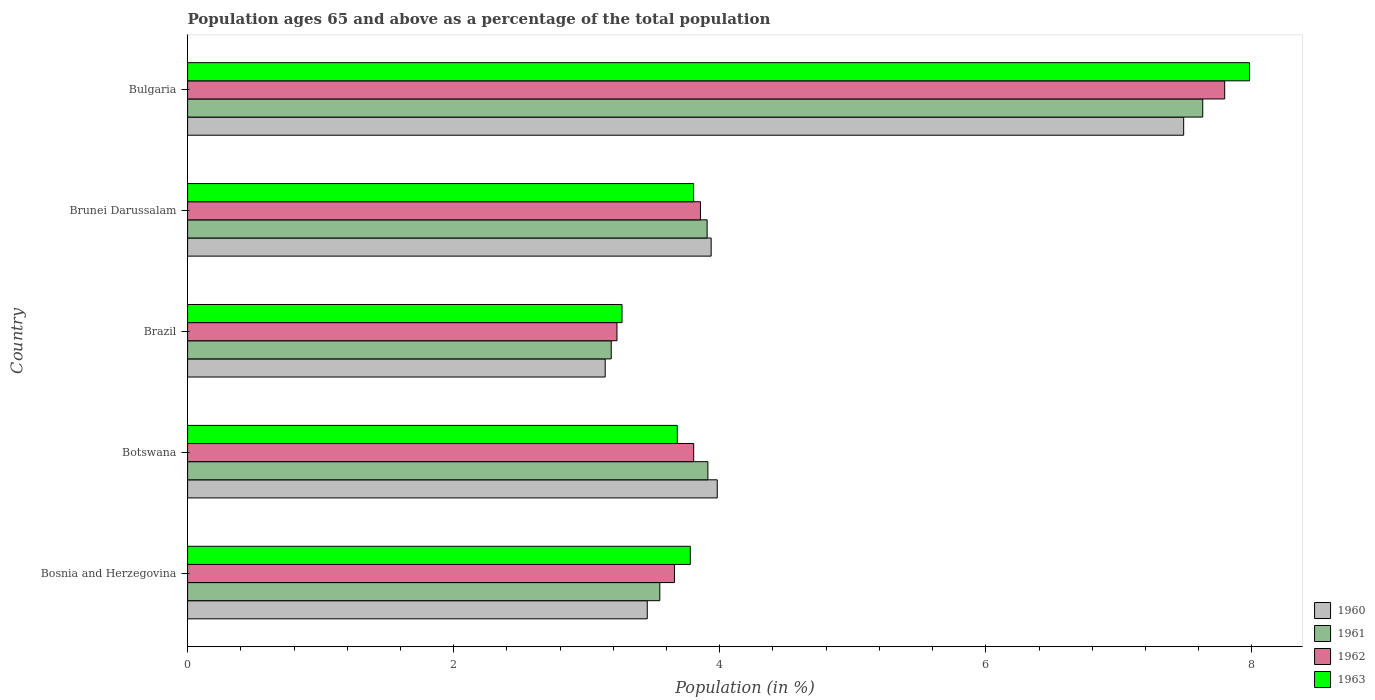How many different coloured bars are there?
Give a very brief answer. 4. How many groups of bars are there?
Give a very brief answer. 5. Are the number of bars on each tick of the Y-axis equal?
Provide a short and direct response. Yes. How many bars are there on the 3rd tick from the bottom?
Keep it short and to the point. 4. What is the label of the 5th group of bars from the top?
Your answer should be compact. Bosnia and Herzegovina. What is the percentage of the population ages 65 and above in 1963 in Botswana?
Ensure brevity in your answer.  3.68. Across all countries, what is the maximum percentage of the population ages 65 and above in 1961?
Provide a short and direct response. 7.63. Across all countries, what is the minimum percentage of the population ages 65 and above in 1961?
Provide a short and direct response. 3.18. What is the total percentage of the population ages 65 and above in 1962 in the graph?
Ensure brevity in your answer.  22.34. What is the difference between the percentage of the population ages 65 and above in 1960 in Bosnia and Herzegovina and that in Botswana?
Your answer should be very brief. -0.53. What is the difference between the percentage of the population ages 65 and above in 1960 in Botswana and the percentage of the population ages 65 and above in 1963 in Brazil?
Keep it short and to the point. 0.72. What is the average percentage of the population ages 65 and above in 1961 per country?
Make the answer very short. 4.44. What is the difference between the percentage of the population ages 65 and above in 1961 and percentage of the population ages 65 and above in 1962 in Bosnia and Herzegovina?
Offer a very short reply. -0.11. In how many countries, is the percentage of the population ages 65 and above in 1961 greater than 3.6 ?
Give a very brief answer. 3. What is the ratio of the percentage of the population ages 65 and above in 1962 in Brunei Darussalam to that in Bulgaria?
Offer a terse response. 0.49. Is the percentage of the population ages 65 and above in 1960 in Bosnia and Herzegovina less than that in Bulgaria?
Your response must be concise. Yes. What is the difference between the highest and the second highest percentage of the population ages 65 and above in 1962?
Provide a succinct answer. 3.94. What is the difference between the highest and the lowest percentage of the population ages 65 and above in 1963?
Make the answer very short. 4.72. Is it the case that in every country, the sum of the percentage of the population ages 65 and above in 1962 and percentage of the population ages 65 and above in 1961 is greater than the sum of percentage of the population ages 65 and above in 1960 and percentage of the population ages 65 and above in 1963?
Make the answer very short. No. What does the 2nd bar from the top in Brazil represents?
Your answer should be compact. 1962. Is it the case that in every country, the sum of the percentage of the population ages 65 and above in 1961 and percentage of the population ages 65 and above in 1960 is greater than the percentage of the population ages 65 and above in 1963?
Make the answer very short. Yes. How many bars are there?
Your answer should be compact. 20. Are all the bars in the graph horizontal?
Offer a terse response. Yes. What is the difference between two consecutive major ticks on the X-axis?
Ensure brevity in your answer.  2. Where does the legend appear in the graph?
Offer a very short reply. Bottom right. How many legend labels are there?
Your response must be concise. 4. What is the title of the graph?
Offer a terse response. Population ages 65 and above as a percentage of the total population. What is the label or title of the X-axis?
Provide a short and direct response. Population (in %). What is the Population (in %) of 1960 in Bosnia and Herzegovina?
Offer a terse response. 3.46. What is the Population (in %) of 1961 in Bosnia and Herzegovina?
Give a very brief answer. 3.55. What is the Population (in %) in 1962 in Bosnia and Herzegovina?
Offer a very short reply. 3.66. What is the Population (in %) of 1963 in Bosnia and Herzegovina?
Ensure brevity in your answer.  3.78. What is the Population (in %) in 1960 in Botswana?
Offer a very short reply. 3.98. What is the Population (in %) of 1961 in Botswana?
Your answer should be very brief. 3.91. What is the Population (in %) in 1962 in Botswana?
Provide a succinct answer. 3.8. What is the Population (in %) in 1963 in Botswana?
Ensure brevity in your answer.  3.68. What is the Population (in %) of 1960 in Brazil?
Ensure brevity in your answer.  3.14. What is the Population (in %) of 1961 in Brazil?
Ensure brevity in your answer.  3.18. What is the Population (in %) of 1962 in Brazil?
Provide a short and direct response. 3.23. What is the Population (in %) in 1963 in Brazil?
Provide a succinct answer. 3.27. What is the Population (in %) in 1960 in Brunei Darussalam?
Make the answer very short. 3.94. What is the Population (in %) of 1961 in Brunei Darussalam?
Make the answer very short. 3.9. What is the Population (in %) of 1962 in Brunei Darussalam?
Keep it short and to the point. 3.85. What is the Population (in %) in 1963 in Brunei Darussalam?
Give a very brief answer. 3.8. What is the Population (in %) in 1960 in Bulgaria?
Offer a terse response. 7.49. What is the Population (in %) of 1961 in Bulgaria?
Make the answer very short. 7.63. What is the Population (in %) in 1962 in Bulgaria?
Your answer should be compact. 7.8. What is the Population (in %) in 1963 in Bulgaria?
Provide a short and direct response. 7.98. Across all countries, what is the maximum Population (in %) of 1960?
Provide a succinct answer. 7.49. Across all countries, what is the maximum Population (in %) in 1961?
Offer a terse response. 7.63. Across all countries, what is the maximum Population (in %) in 1962?
Offer a terse response. 7.8. Across all countries, what is the maximum Population (in %) of 1963?
Your answer should be very brief. 7.98. Across all countries, what is the minimum Population (in %) of 1960?
Your answer should be compact. 3.14. Across all countries, what is the minimum Population (in %) of 1961?
Your answer should be compact. 3.18. Across all countries, what is the minimum Population (in %) in 1962?
Give a very brief answer. 3.23. Across all countries, what is the minimum Population (in %) of 1963?
Offer a very short reply. 3.27. What is the total Population (in %) in 1960 in the graph?
Your answer should be very brief. 22. What is the total Population (in %) in 1961 in the graph?
Keep it short and to the point. 22.18. What is the total Population (in %) of 1962 in the graph?
Offer a very short reply. 22.34. What is the total Population (in %) of 1963 in the graph?
Your response must be concise. 22.51. What is the difference between the Population (in %) in 1960 in Bosnia and Herzegovina and that in Botswana?
Give a very brief answer. -0.53. What is the difference between the Population (in %) in 1961 in Bosnia and Herzegovina and that in Botswana?
Your answer should be very brief. -0.36. What is the difference between the Population (in %) in 1962 in Bosnia and Herzegovina and that in Botswana?
Make the answer very short. -0.14. What is the difference between the Population (in %) of 1963 in Bosnia and Herzegovina and that in Botswana?
Offer a very short reply. 0.1. What is the difference between the Population (in %) of 1960 in Bosnia and Herzegovina and that in Brazil?
Make the answer very short. 0.32. What is the difference between the Population (in %) in 1961 in Bosnia and Herzegovina and that in Brazil?
Offer a terse response. 0.37. What is the difference between the Population (in %) in 1962 in Bosnia and Herzegovina and that in Brazil?
Provide a succinct answer. 0.43. What is the difference between the Population (in %) in 1963 in Bosnia and Herzegovina and that in Brazil?
Give a very brief answer. 0.51. What is the difference between the Population (in %) of 1960 in Bosnia and Herzegovina and that in Brunei Darussalam?
Provide a short and direct response. -0.48. What is the difference between the Population (in %) in 1961 in Bosnia and Herzegovina and that in Brunei Darussalam?
Provide a succinct answer. -0.36. What is the difference between the Population (in %) of 1962 in Bosnia and Herzegovina and that in Brunei Darussalam?
Provide a short and direct response. -0.2. What is the difference between the Population (in %) in 1963 in Bosnia and Herzegovina and that in Brunei Darussalam?
Keep it short and to the point. -0.02. What is the difference between the Population (in %) of 1960 in Bosnia and Herzegovina and that in Bulgaria?
Provide a short and direct response. -4.03. What is the difference between the Population (in %) in 1961 in Bosnia and Herzegovina and that in Bulgaria?
Keep it short and to the point. -4.08. What is the difference between the Population (in %) of 1962 in Bosnia and Herzegovina and that in Bulgaria?
Your answer should be very brief. -4.14. What is the difference between the Population (in %) of 1963 in Bosnia and Herzegovina and that in Bulgaria?
Offer a very short reply. -4.2. What is the difference between the Population (in %) in 1960 in Botswana and that in Brazil?
Ensure brevity in your answer.  0.84. What is the difference between the Population (in %) in 1961 in Botswana and that in Brazil?
Your response must be concise. 0.73. What is the difference between the Population (in %) in 1962 in Botswana and that in Brazil?
Your response must be concise. 0.58. What is the difference between the Population (in %) of 1963 in Botswana and that in Brazil?
Provide a short and direct response. 0.42. What is the difference between the Population (in %) of 1960 in Botswana and that in Brunei Darussalam?
Give a very brief answer. 0.05. What is the difference between the Population (in %) in 1961 in Botswana and that in Brunei Darussalam?
Ensure brevity in your answer.  0.01. What is the difference between the Population (in %) of 1962 in Botswana and that in Brunei Darussalam?
Provide a short and direct response. -0.05. What is the difference between the Population (in %) in 1963 in Botswana and that in Brunei Darussalam?
Your answer should be very brief. -0.12. What is the difference between the Population (in %) of 1960 in Botswana and that in Bulgaria?
Offer a very short reply. -3.51. What is the difference between the Population (in %) in 1961 in Botswana and that in Bulgaria?
Offer a terse response. -3.72. What is the difference between the Population (in %) of 1962 in Botswana and that in Bulgaria?
Offer a terse response. -3.99. What is the difference between the Population (in %) in 1963 in Botswana and that in Bulgaria?
Ensure brevity in your answer.  -4.3. What is the difference between the Population (in %) in 1960 in Brazil and that in Brunei Darussalam?
Offer a very short reply. -0.8. What is the difference between the Population (in %) of 1961 in Brazil and that in Brunei Darussalam?
Your answer should be compact. -0.72. What is the difference between the Population (in %) of 1962 in Brazil and that in Brunei Darussalam?
Ensure brevity in your answer.  -0.63. What is the difference between the Population (in %) of 1963 in Brazil and that in Brunei Darussalam?
Your answer should be compact. -0.54. What is the difference between the Population (in %) in 1960 in Brazil and that in Bulgaria?
Provide a succinct answer. -4.35. What is the difference between the Population (in %) in 1961 in Brazil and that in Bulgaria?
Make the answer very short. -4.45. What is the difference between the Population (in %) of 1962 in Brazil and that in Bulgaria?
Your answer should be compact. -4.57. What is the difference between the Population (in %) in 1963 in Brazil and that in Bulgaria?
Your answer should be compact. -4.72. What is the difference between the Population (in %) in 1960 in Brunei Darussalam and that in Bulgaria?
Make the answer very short. -3.55. What is the difference between the Population (in %) in 1961 in Brunei Darussalam and that in Bulgaria?
Make the answer very short. -3.73. What is the difference between the Population (in %) of 1962 in Brunei Darussalam and that in Bulgaria?
Offer a very short reply. -3.94. What is the difference between the Population (in %) in 1963 in Brunei Darussalam and that in Bulgaria?
Ensure brevity in your answer.  -4.18. What is the difference between the Population (in %) of 1960 in Bosnia and Herzegovina and the Population (in %) of 1961 in Botswana?
Provide a succinct answer. -0.46. What is the difference between the Population (in %) of 1960 in Bosnia and Herzegovina and the Population (in %) of 1962 in Botswana?
Provide a succinct answer. -0.35. What is the difference between the Population (in %) of 1960 in Bosnia and Herzegovina and the Population (in %) of 1963 in Botswana?
Your response must be concise. -0.23. What is the difference between the Population (in %) of 1961 in Bosnia and Herzegovina and the Population (in %) of 1962 in Botswana?
Make the answer very short. -0.25. What is the difference between the Population (in %) in 1961 in Bosnia and Herzegovina and the Population (in %) in 1963 in Botswana?
Provide a succinct answer. -0.13. What is the difference between the Population (in %) of 1962 in Bosnia and Herzegovina and the Population (in %) of 1963 in Botswana?
Your response must be concise. -0.02. What is the difference between the Population (in %) of 1960 in Bosnia and Herzegovina and the Population (in %) of 1961 in Brazil?
Make the answer very short. 0.27. What is the difference between the Population (in %) of 1960 in Bosnia and Herzegovina and the Population (in %) of 1962 in Brazil?
Offer a terse response. 0.23. What is the difference between the Population (in %) in 1960 in Bosnia and Herzegovina and the Population (in %) in 1963 in Brazil?
Offer a terse response. 0.19. What is the difference between the Population (in %) in 1961 in Bosnia and Herzegovina and the Population (in %) in 1962 in Brazil?
Keep it short and to the point. 0.32. What is the difference between the Population (in %) in 1961 in Bosnia and Herzegovina and the Population (in %) in 1963 in Brazil?
Your answer should be very brief. 0.28. What is the difference between the Population (in %) of 1962 in Bosnia and Herzegovina and the Population (in %) of 1963 in Brazil?
Give a very brief answer. 0.39. What is the difference between the Population (in %) of 1960 in Bosnia and Herzegovina and the Population (in %) of 1961 in Brunei Darussalam?
Your response must be concise. -0.45. What is the difference between the Population (in %) in 1960 in Bosnia and Herzegovina and the Population (in %) in 1962 in Brunei Darussalam?
Ensure brevity in your answer.  -0.4. What is the difference between the Population (in %) in 1960 in Bosnia and Herzegovina and the Population (in %) in 1963 in Brunei Darussalam?
Make the answer very short. -0.35. What is the difference between the Population (in %) of 1961 in Bosnia and Herzegovina and the Population (in %) of 1962 in Brunei Darussalam?
Your answer should be very brief. -0.31. What is the difference between the Population (in %) in 1961 in Bosnia and Herzegovina and the Population (in %) in 1963 in Brunei Darussalam?
Ensure brevity in your answer.  -0.25. What is the difference between the Population (in %) in 1962 in Bosnia and Herzegovina and the Population (in %) in 1963 in Brunei Darussalam?
Ensure brevity in your answer.  -0.14. What is the difference between the Population (in %) in 1960 in Bosnia and Herzegovina and the Population (in %) in 1961 in Bulgaria?
Your response must be concise. -4.18. What is the difference between the Population (in %) of 1960 in Bosnia and Herzegovina and the Population (in %) of 1962 in Bulgaria?
Offer a terse response. -4.34. What is the difference between the Population (in %) in 1960 in Bosnia and Herzegovina and the Population (in %) in 1963 in Bulgaria?
Your answer should be very brief. -4.53. What is the difference between the Population (in %) in 1961 in Bosnia and Herzegovina and the Population (in %) in 1962 in Bulgaria?
Your answer should be compact. -4.25. What is the difference between the Population (in %) of 1961 in Bosnia and Herzegovina and the Population (in %) of 1963 in Bulgaria?
Your answer should be compact. -4.43. What is the difference between the Population (in %) in 1962 in Bosnia and Herzegovina and the Population (in %) in 1963 in Bulgaria?
Make the answer very short. -4.32. What is the difference between the Population (in %) of 1960 in Botswana and the Population (in %) of 1961 in Brazil?
Keep it short and to the point. 0.8. What is the difference between the Population (in %) of 1960 in Botswana and the Population (in %) of 1962 in Brazil?
Keep it short and to the point. 0.75. What is the difference between the Population (in %) of 1960 in Botswana and the Population (in %) of 1963 in Brazil?
Your response must be concise. 0.72. What is the difference between the Population (in %) in 1961 in Botswana and the Population (in %) in 1962 in Brazil?
Your answer should be very brief. 0.68. What is the difference between the Population (in %) in 1961 in Botswana and the Population (in %) in 1963 in Brazil?
Give a very brief answer. 0.65. What is the difference between the Population (in %) in 1962 in Botswana and the Population (in %) in 1963 in Brazil?
Offer a terse response. 0.54. What is the difference between the Population (in %) in 1960 in Botswana and the Population (in %) in 1961 in Brunei Darussalam?
Give a very brief answer. 0.08. What is the difference between the Population (in %) of 1960 in Botswana and the Population (in %) of 1962 in Brunei Darussalam?
Make the answer very short. 0.13. What is the difference between the Population (in %) in 1960 in Botswana and the Population (in %) in 1963 in Brunei Darussalam?
Offer a very short reply. 0.18. What is the difference between the Population (in %) of 1961 in Botswana and the Population (in %) of 1962 in Brunei Darussalam?
Your answer should be very brief. 0.06. What is the difference between the Population (in %) in 1961 in Botswana and the Population (in %) in 1963 in Brunei Darussalam?
Your answer should be compact. 0.11. What is the difference between the Population (in %) in 1962 in Botswana and the Population (in %) in 1963 in Brunei Darussalam?
Provide a succinct answer. 0. What is the difference between the Population (in %) of 1960 in Botswana and the Population (in %) of 1961 in Bulgaria?
Make the answer very short. -3.65. What is the difference between the Population (in %) in 1960 in Botswana and the Population (in %) in 1962 in Bulgaria?
Your answer should be very brief. -3.81. What is the difference between the Population (in %) of 1960 in Botswana and the Population (in %) of 1963 in Bulgaria?
Make the answer very short. -4. What is the difference between the Population (in %) in 1961 in Botswana and the Population (in %) in 1962 in Bulgaria?
Your answer should be very brief. -3.88. What is the difference between the Population (in %) of 1961 in Botswana and the Population (in %) of 1963 in Bulgaria?
Give a very brief answer. -4.07. What is the difference between the Population (in %) in 1962 in Botswana and the Population (in %) in 1963 in Bulgaria?
Offer a terse response. -4.18. What is the difference between the Population (in %) of 1960 in Brazil and the Population (in %) of 1961 in Brunei Darussalam?
Ensure brevity in your answer.  -0.77. What is the difference between the Population (in %) of 1960 in Brazil and the Population (in %) of 1962 in Brunei Darussalam?
Provide a short and direct response. -0.72. What is the difference between the Population (in %) of 1960 in Brazil and the Population (in %) of 1963 in Brunei Darussalam?
Give a very brief answer. -0.66. What is the difference between the Population (in %) of 1961 in Brazil and the Population (in %) of 1962 in Brunei Darussalam?
Make the answer very short. -0.67. What is the difference between the Population (in %) in 1961 in Brazil and the Population (in %) in 1963 in Brunei Darussalam?
Offer a terse response. -0.62. What is the difference between the Population (in %) in 1962 in Brazil and the Population (in %) in 1963 in Brunei Darussalam?
Provide a short and direct response. -0.58. What is the difference between the Population (in %) in 1960 in Brazil and the Population (in %) in 1961 in Bulgaria?
Provide a short and direct response. -4.49. What is the difference between the Population (in %) of 1960 in Brazil and the Population (in %) of 1962 in Bulgaria?
Make the answer very short. -4.66. What is the difference between the Population (in %) of 1960 in Brazil and the Population (in %) of 1963 in Bulgaria?
Your answer should be very brief. -4.84. What is the difference between the Population (in %) in 1961 in Brazil and the Population (in %) in 1962 in Bulgaria?
Ensure brevity in your answer.  -4.61. What is the difference between the Population (in %) of 1961 in Brazil and the Population (in %) of 1963 in Bulgaria?
Offer a terse response. -4.8. What is the difference between the Population (in %) of 1962 in Brazil and the Population (in %) of 1963 in Bulgaria?
Ensure brevity in your answer.  -4.75. What is the difference between the Population (in %) of 1960 in Brunei Darussalam and the Population (in %) of 1961 in Bulgaria?
Offer a terse response. -3.69. What is the difference between the Population (in %) in 1960 in Brunei Darussalam and the Population (in %) in 1962 in Bulgaria?
Give a very brief answer. -3.86. What is the difference between the Population (in %) in 1960 in Brunei Darussalam and the Population (in %) in 1963 in Bulgaria?
Your answer should be compact. -4.05. What is the difference between the Population (in %) of 1961 in Brunei Darussalam and the Population (in %) of 1962 in Bulgaria?
Ensure brevity in your answer.  -3.89. What is the difference between the Population (in %) in 1961 in Brunei Darussalam and the Population (in %) in 1963 in Bulgaria?
Keep it short and to the point. -4.08. What is the difference between the Population (in %) of 1962 in Brunei Darussalam and the Population (in %) of 1963 in Bulgaria?
Your response must be concise. -4.13. What is the average Population (in %) of 1960 per country?
Make the answer very short. 4.4. What is the average Population (in %) in 1961 per country?
Ensure brevity in your answer.  4.44. What is the average Population (in %) in 1962 per country?
Provide a short and direct response. 4.47. What is the average Population (in %) of 1963 per country?
Offer a terse response. 4.5. What is the difference between the Population (in %) in 1960 and Population (in %) in 1961 in Bosnia and Herzegovina?
Your answer should be compact. -0.09. What is the difference between the Population (in %) of 1960 and Population (in %) of 1962 in Bosnia and Herzegovina?
Ensure brevity in your answer.  -0.2. What is the difference between the Population (in %) of 1960 and Population (in %) of 1963 in Bosnia and Herzegovina?
Provide a succinct answer. -0.32. What is the difference between the Population (in %) in 1961 and Population (in %) in 1962 in Bosnia and Herzegovina?
Offer a terse response. -0.11. What is the difference between the Population (in %) in 1961 and Population (in %) in 1963 in Bosnia and Herzegovina?
Your answer should be very brief. -0.23. What is the difference between the Population (in %) in 1962 and Population (in %) in 1963 in Bosnia and Herzegovina?
Keep it short and to the point. -0.12. What is the difference between the Population (in %) in 1960 and Population (in %) in 1961 in Botswana?
Offer a terse response. 0.07. What is the difference between the Population (in %) in 1960 and Population (in %) in 1962 in Botswana?
Your answer should be very brief. 0.18. What is the difference between the Population (in %) of 1960 and Population (in %) of 1963 in Botswana?
Offer a terse response. 0.3. What is the difference between the Population (in %) of 1961 and Population (in %) of 1962 in Botswana?
Provide a succinct answer. 0.11. What is the difference between the Population (in %) in 1961 and Population (in %) in 1963 in Botswana?
Provide a succinct answer. 0.23. What is the difference between the Population (in %) of 1962 and Population (in %) of 1963 in Botswana?
Give a very brief answer. 0.12. What is the difference between the Population (in %) of 1960 and Population (in %) of 1961 in Brazil?
Your answer should be very brief. -0.05. What is the difference between the Population (in %) of 1960 and Population (in %) of 1962 in Brazil?
Offer a very short reply. -0.09. What is the difference between the Population (in %) of 1960 and Population (in %) of 1963 in Brazil?
Your answer should be compact. -0.13. What is the difference between the Population (in %) of 1961 and Population (in %) of 1962 in Brazil?
Offer a terse response. -0.04. What is the difference between the Population (in %) of 1961 and Population (in %) of 1963 in Brazil?
Provide a short and direct response. -0.08. What is the difference between the Population (in %) in 1962 and Population (in %) in 1963 in Brazil?
Make the answer very short. -0.04. What is the difference between the Population (in %) in 1960 and Population (in %) in 1961 in Brunei Darussalam?
Provide a short and direct response. 0.03. What is the difference between the Population (in %) in 1960 and Population (in %) in 1962 in Brunei Darussalam?
Offer a very short reply. 0.08. What is the difference between the Population (in %) in 1960 and Population (in %) in 1963 in Brunei Darussalam?
Give a very brief answer. 0.13. What is the difference between the Population (in %) of 1961 and Population (in %) of 1962 in Brunei Darussalam?
Provide a short and direct response. 0.05. What is the difference between the Population (in %) in 1961 and Population (in %) in 1963 in Brunei Darussalam?
Offer a very short reply. 0.1. What is the difference between the Population (in %) of 1962 and Population (in %) of 1963 in Brunei Darussalam?
Make the answer very short. 0.05. What is the difference between the Population (in %) in 1960 and Population (in %) in 1961 in Bulgaria?
Give a very brief answer. -0.14. What is the difference between the Population (in %) of 1960 and Population (in %) of 1962 in Bulgaria?
Offer a terse response. -0.31. What is the difference between the Population (in %) in 1960 and Population (in %) in 1963 in Bulgaria?
Make the answer very short. -0.49. What is the difference between the Population (in %) in 1961 and Population (in %) in 1962 in Bulgaria?
Provide a succinct answer. -0.17. What is the difference between the Population (in %) of 1961 and Population (in %) of 1963 in Bulgaria?
Your answer should be very brief. -0.35. What is the difference between the Population (in %) in 1962 and Population (in %) in 1963 in Bulgaria?
Provide a succinct answer. -0.19. What is the ratio of the Population (in %) of 1960 in Bosnia and Herzegovina to that in Botswana?
Your response must be concise. 0.87. What is the ratio of the Population (in %) in 1961 in Bosnia and Herzegovina to that in Botswana?
Your response must be concise. 0.91. What is the ratio of the Population (in %) in 1963 in Bosnia and Herzegovina to that in Botswana?
Give a very brief answer. 1.03. What is the ratio of the Population (in %) in 1960 in Bosnia and Herzegovina to that in Brazil?
Ensure brevity in your answer.  1.1. What is the ratio of the Population (in %) of 1961 in Bosnia and Herzegovina to that in Brazil?
Provide a succinct answer. 1.11. What is the ratio of the Population (in %) of 1962 in Bosnia and Herzegovina to that in Brazil?
Offer a very short reply. 1.13. What is the ratio of the Population (in %) in 1963 in Bosnia and Herzegovina to that in Brazil?
Your answer should be very brief. 1.16. What is the ratio of the Population (in %) of 1960 in Bosnia and Herzegovina to that in Brunei Darussalam?
Offer a terse response. 0.88. What is the ratio of the Population (in %) in 1961 in Bosnia and Herzegovina to that in Brunei Darussalam?
Your answer should be very brief. 0.91. What is the ratio of the Population (in %) of 1962 in Bosnia and Herzegovina to that in Brunei Darussalam?
Your answer should be very brief. 0.95. What is the ratio of the Population (in %) of 1960 in Bosnia and Herzegovina to that in Bulgaria?
Your answer should be very brief. 0.46. What is the ratio of the Population (in %) of 1961 in Bosnia and Herzegovina to that in Bulgaria?
Keep it short and to the point. 0.47. What is the ratio of the Population (in %) of 1962 in Bosnia and Herzegovina to that in Bulgaria?
Offer a very short reply. 0.47. What is the ratio of the Population (in %) of 1963 in Bosnia and Herzegovina to that in Bulgaria?
Offer a terse response. 0.47. What is the ratio of the Population (in %) of 1960 in Botswana to that in Brazil?
Your response must be concise. 1.27. What is the ratio of the Population (in %) in 1961 in Botswana to that in Brazil?
Ensure brevity in your answer.  1.23. What is the ratio of the Population (in %) of 1962 in Botswana to that in Brazil?
Provide a succinct answer. 1.18. What is the ratio of the Population (in %) in 1963 in Botswana to that in Brazil?
Offer a very short reply. 1.13. What is the ratio of the Population (in %) of 1960 in Botswana to that in Brunei Darussalam?
Make the answer very short. 1.01. What is the ratio of the Population (in %) of 1962 in Botswana to that in Brunei Darussalam?
Ensure brevity in your answer.  0.99. What is the ratio of the Population (in %) in 1963 in Botswana to that in Brunei Darussalam?
Your answer should be compact. 0.97. What is the ratio of the Population (in %) of 1960 in Botswana to that in Bulgaria?
Offer a very short reply. 0.53. What is the ratio of the Population (in %) in 1961 in Botswana to that in Bulgaria?
Ensure brevity in your answer.  0.51. What is the ratio of the Population (in %) of 1962 in Botswana to that in Bulgaria?
Offer a very short reply. 0.49. What is the ratio of the Population (in %) of 1963 in Botswana to that in Bulgaria?
Offer a very short reply. 0.46. What is the ratio of the Population (in %) in 1960 in Brazil to that in Brunei Darussalam?
Provide a succinct answer. 0.8. What is the ratio of the Population (in %) of 1961 in Brazil to that in Brunei Darussalam?
Your answer should be very brief. 0.82. What is the ratio of the Population (in %) in 1962 in Brazil to that in Brunei Darussalam?
Make the answer very short. 0.84. What is the ratio of the Population (in %) of 1963 in Brazil to that in Brunei Darussalam?
Ensure brevity in your answer.  0.86. What is the ratio of the Population (in %) in 1960 in Brazil to that in Bulgaria?
Your answer should be compact. 0.42. What is the ratio of the Population (in %) of 1961 in Brazil to that in Bulgaria?
Keep it short and to the point. 0.42. What is the ratio of the Population (in %) of 1962 in Brazil to that in Bulgaria?
Your answer should be compact. 0.41. What is the ratio of the Population (in %) of 1963 in Brazil to that in Bulgaria?
Ensure brevity in your answer.  0.41. What is the ratio of the Population (in %) of 1960 in Brunei Darussalam to that in Bulgaria?
Make the answer very short. 0.53. What is the ratio of the Population (in %) of 1961 in Brunei Darussalam to that in Bulgaria?
Keep it short and to the point. 0.51. What is the ratio of the Population (in %) of 1962 in Brunei Darussalam to that in Bulgaria?
Ensure brevity in your answer.  0.49. What is the ratio of the Population (in %) of 1963 in Brunei Darussalam to that in Bulgaria?
Provide a short and direct response. 0.48. What is the difference between the highest and the second highest Population (in %) of 1960?
Provide a succinct answer. 3.51. What is the difference between the highest and the second highest Population (in %) in 1961?
Make the answer very short. 3.72. What is the difference between the highest and the second highest Population (in %) in 1962?
Ensure brevity in your answer.  3.94. What is the difference between the highest and the second highest Population (in %) in 1963?
Offer a very short reply. 4.18. What is the difference between the highest and the lowest Population (in %) of 1960?
Your answer should be compact. 4.35. What is the difference between the highest and the lowest Population (in %) of 1961?
Offer a terse response. 4.45. What is the difference between the highest and the lowest Population (in %) in 1962?
Provide a succinct answer. 4.57. What is the difference between the highest and the lowest Population (in %) in 1963?
Ensure brevity in your answer.  4.72. 